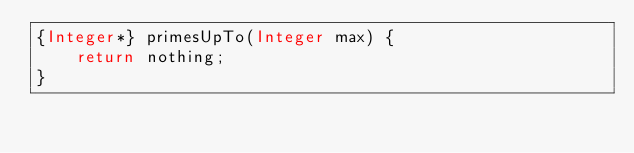<code> <loc_0><loc_0><loc_500><loc_500><_Ceylon_>{Integer*} primesUpTo(Integer max) {
    return nothing;
}
</code> 